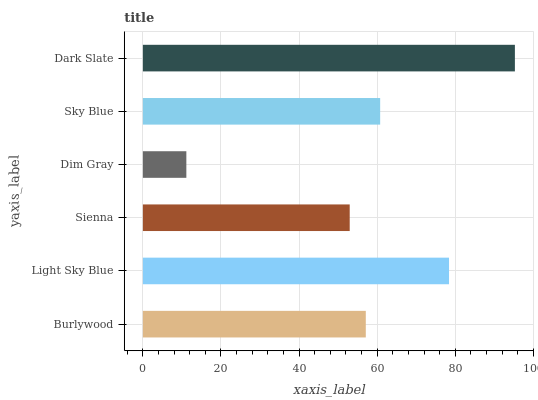Is Dim Gray the minimum?
Answer yes or no. Yes. Is Dark Slate the maximum?
Answer yes or no. Yes. Is Light Sky Blue the minimum?
Answer yes or no. No. Is Light Sky Blue the maximum?
Answer yes or no. No. Is Light Sky Blue greater than Burlywood?
Answer yes or no. Yes. Is Burlywood less than Light Sky Blue?
Answer yes or no. Yes. Is Burlywood greater than Light Sky Blue?
Answer yes or no. No. Is Light Sky Blue less than Burlywood?
Answer yes or no. No. Is Sky Blue the high median?
Answer yes or no. Yes. Is Burlywood the low median?
Answer yes or no. Yes. Is Sienna the high median?
Answer yes or no. No. Is Sky Blue the low median?
Answer yes or no. No. 